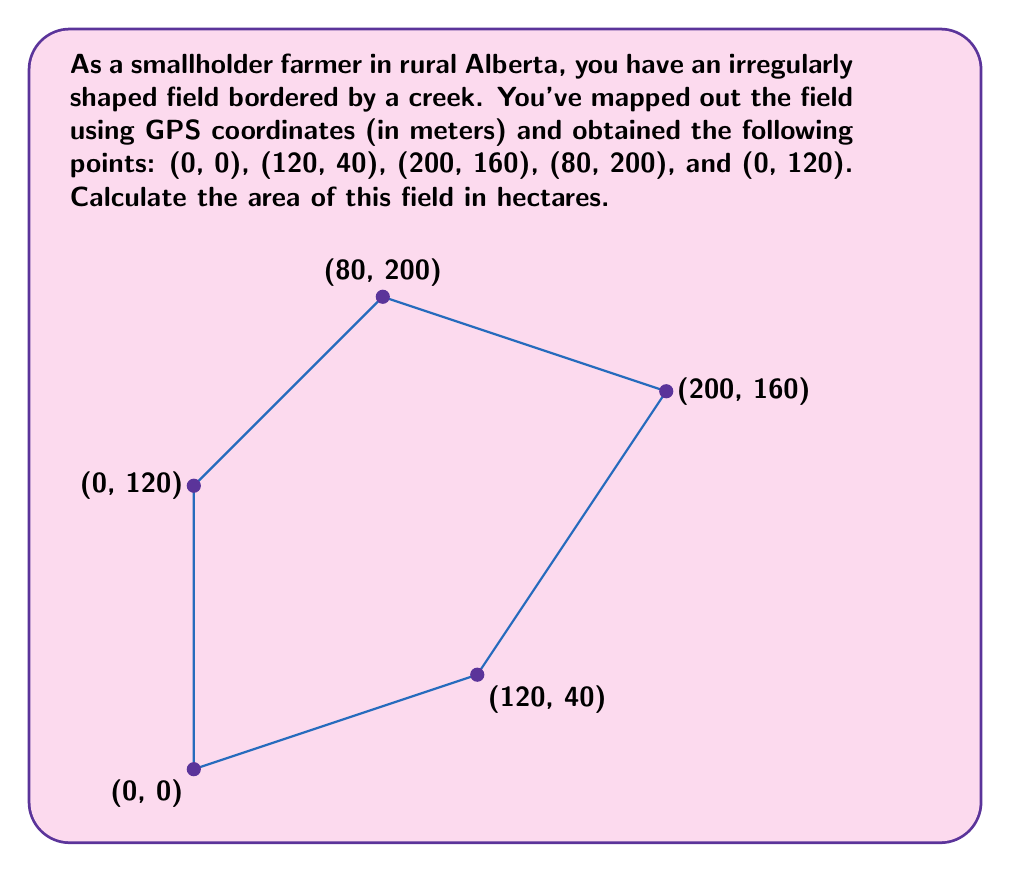Provide a solution to this math problem. To calculate the area of this irregularly shaped field, we can use the Shoelace formula (also known as the surveyor's formula). This method is particularly useful for finding the area of a polygon given its vertices.

The Shoelace formula is:

$$ A = \frac{1}{2}|\sum_{i=1}^{n-1} (x_i y_{i+1} + x_n y_1) - \sum_{i=1}^{n-1} (y_i x_{i+1} + y_n x_1)| $$

Where $(x_i, y_i)$ are the coordinates of the $i$-th vertex.

Let's apply this formula to our field:

1) First, let's organize our points:
   $(x_1, y_1) = (0, 0)$
   $(x_2, y_2) = (120, 40)$
   $(x_3, y_3) = (200, 160)$
   $(x_4, y_4) = (80, 200)$
   $(x_5, y_5) = (0, 120)$

2) Now, let's calculate the first sum:
   $0 \cdot 40 + 120 \cdot 160 + 200 \cdot 200 + 80 \cdot 120 + 0 \cdot 0 = 59200$

3) Calculate the second sum:
   $0 \cdot 120 + 40 \cdot 200 + 160 \cdot 80 + 200 \cdot 0 + 120 \cdot 0 = 20800$

4) Subtract the second sum from the first:
   $59200 - 20800 = 38400$

5) Divide by 2:
   $38400 / 2 = 19200$

6) The result is the area in square meters. To convert to hectares, divide by 10,000:
   $19200 / 10000 = 1.92$ hectares

Therefore, the area of the field is 1.92 hectares.
Answer: $1.92$ hectares 